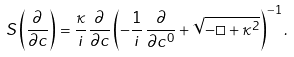Convert formula to latex. <formula><loc_0><loc_0><loc_500><loc_500>S \left ( \frac { \partial } { \partial c } \right ) = \frac { \kappa } { i } \frac { \partial } { \partial c } \left ( - \frac { 1 } { i } \, \frac { \partial } { \partial c ^ { 0 } } + \sqrt { - \Box + \kappa ^ { 2 } } \right ) ^ { - 1 } .</formula> 